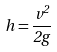Convert formula to latex. <formula><loc_0><loc_0><loc_500><loc_500>h = \frac { v ^ { 2 } } { 2 g }</formula> 